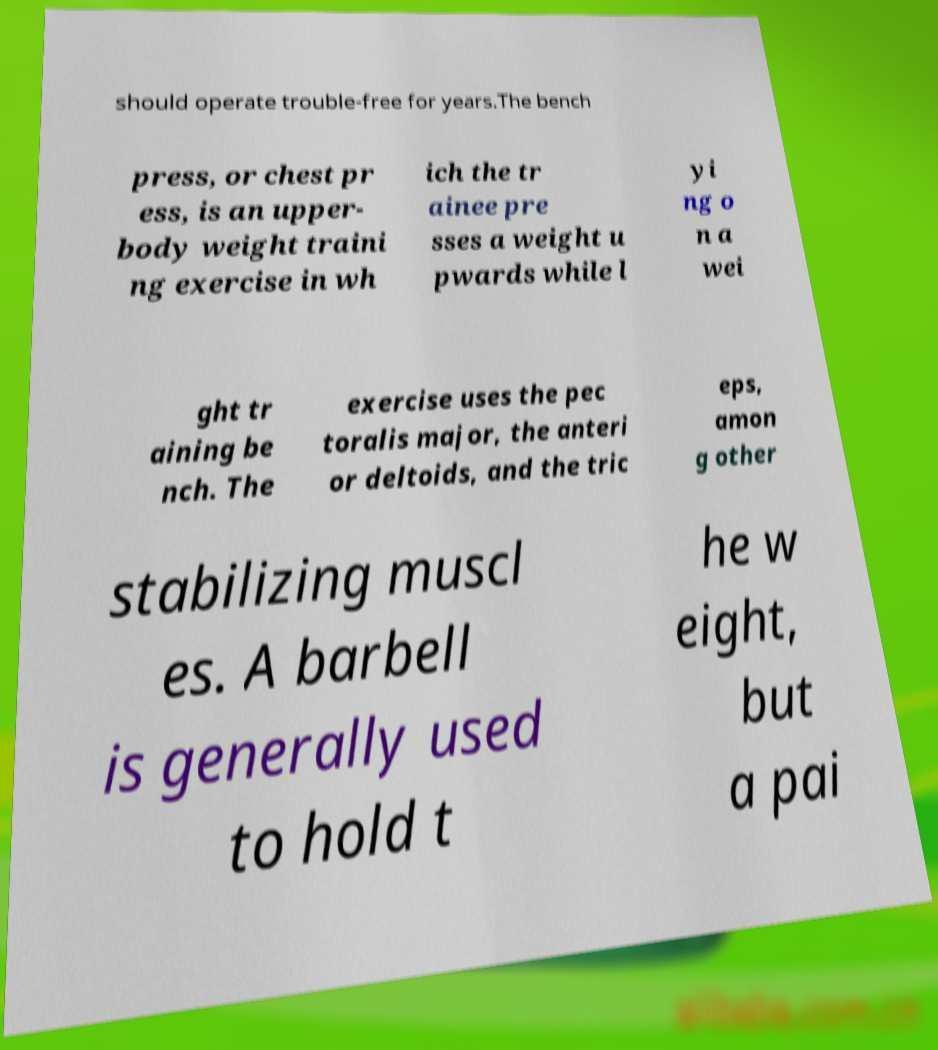I need the written content from this picture converted into text. Can you do that? should operate trouble-free for years.The bench press, or chest pr ess, is an upper- body weight traini ng exercise in wh ich the tr ainee pre sses a weight u pwards while l yi ng o n a wei ght tr aining be nch. The exercise uses the pec toralis major, the anteri or deltoids, and the tric eps, amon g other stabilizing muscl es. A barbell is generally used to hold t he w eight, but a pai 